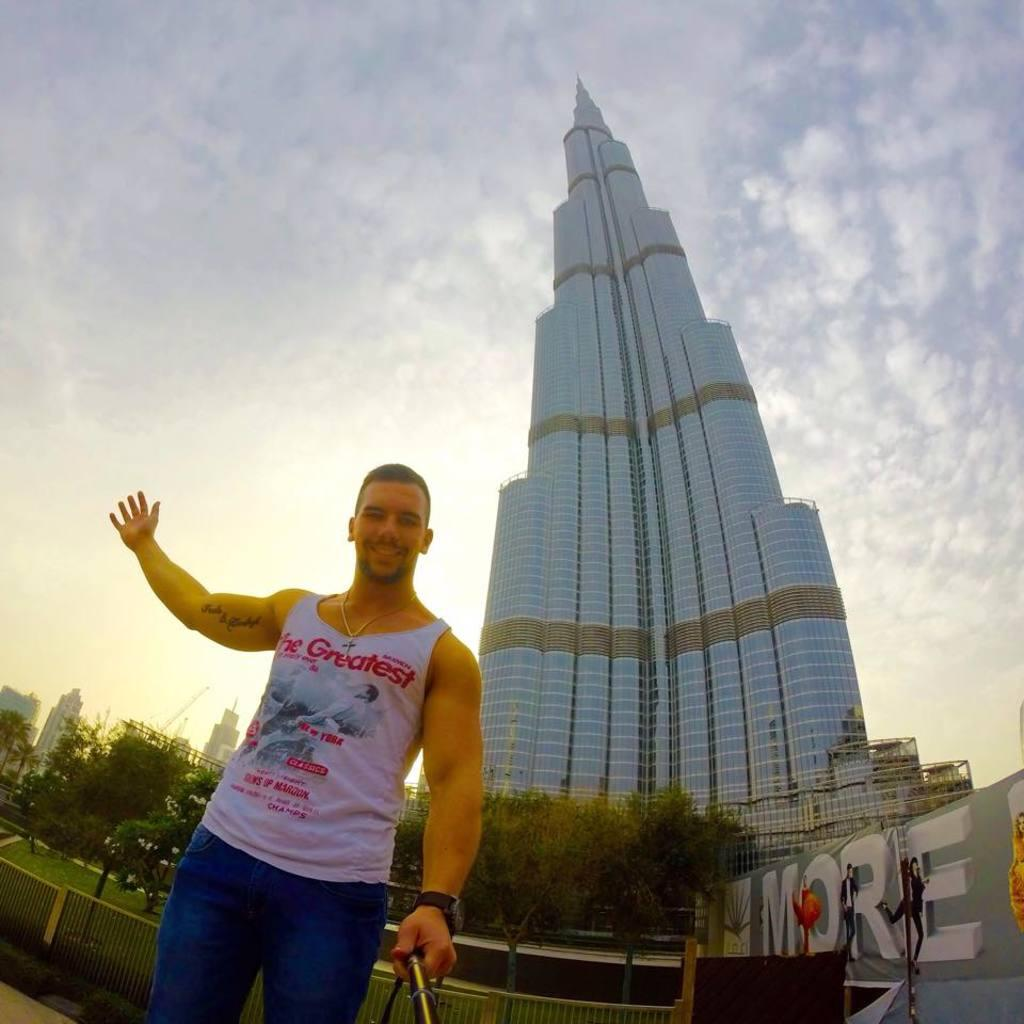What is the man in the image doing? The man is standing in the image and holding a stick in his hand. What can be seen in the background of the image? There are buildings and trees visible in the image. What type of wren can be seen flying near the man in the image? There is no wren present in the image; only the man, the stick, buildings, and trees are visible. 